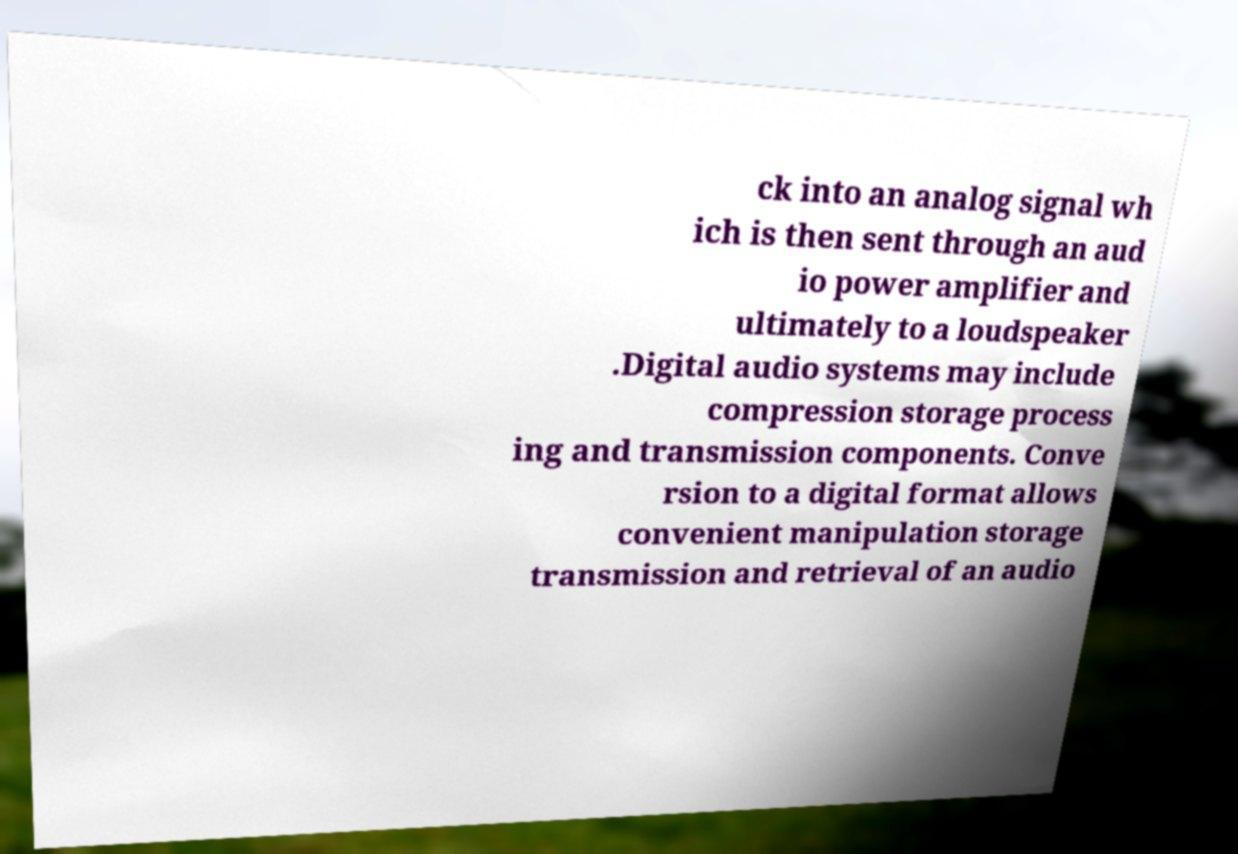For documentation purposes, I need the text within this image transcribed. Could you provide that? ck into an analog signal wh ich is then sent through an aud io power amplifier and ultimately to a loudspeaker .Digital audio systems may include compression storage process ing and transmission components. Conve rsion to a digital format allows convenient manipulation storage transmission and retrieval of an audio 